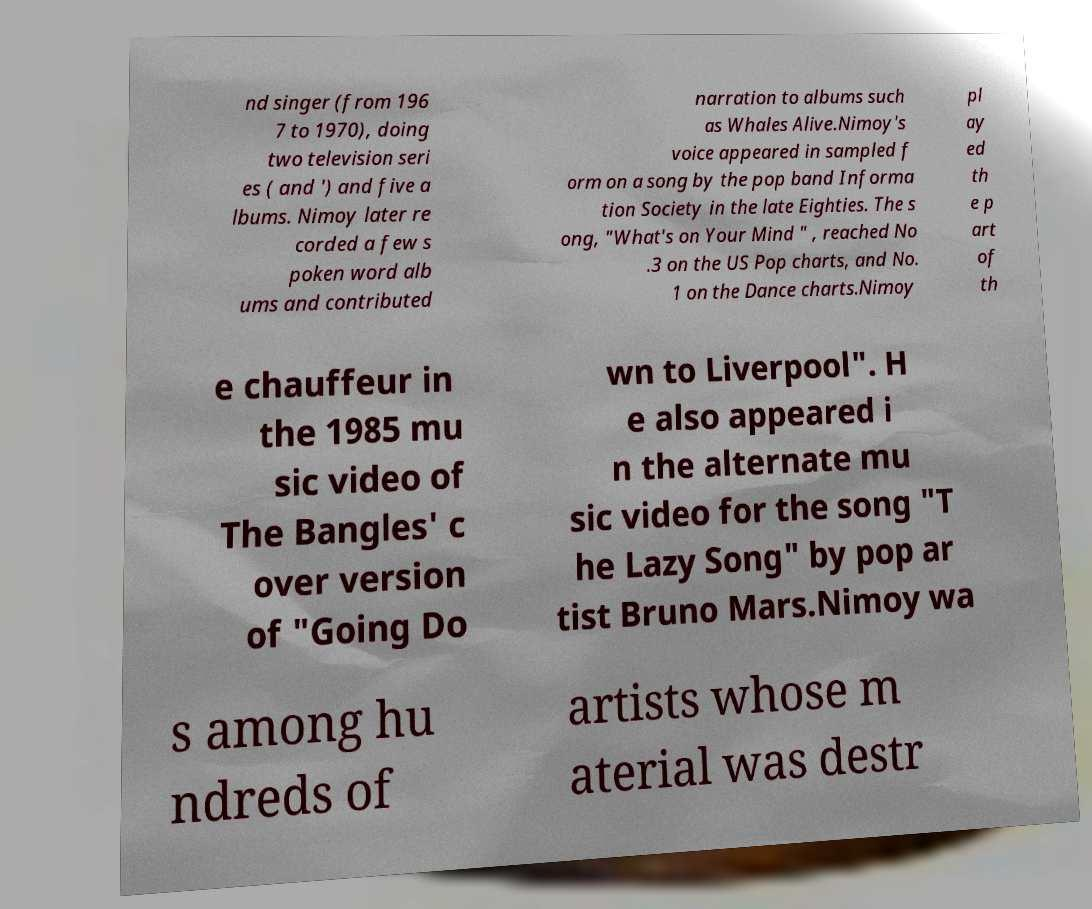There's text embedded in this image that I need extracted. Can you transcribe it verbatim? nd singer (from 196 7 to 1970), doing two television seri es ( and ') and five a lbums. Nimoy later re corded a few s poken word alb ums and contributed narration to albums such as Whales Alive.Nimoy's voice appeared in sampled f orm on a song by the pop band Informa tion Society in the late Eighties. The s ong, "What's on Your Mind " , reached No .3 on the US Pop charts, and No. 1 on the Dance charts.Nimoy pl ay ed th e p art of th e chauffeur in the 1985 mu sic video of The Bangles' c over version of "Going Do wn to Liverpool". H e also appeared i n the alternate mu sic video for the song "T he Lazy Song" by pop ar tist Bruno Mars.Nimoy wa s among hu ndreds of artists whose m aterial was destr 